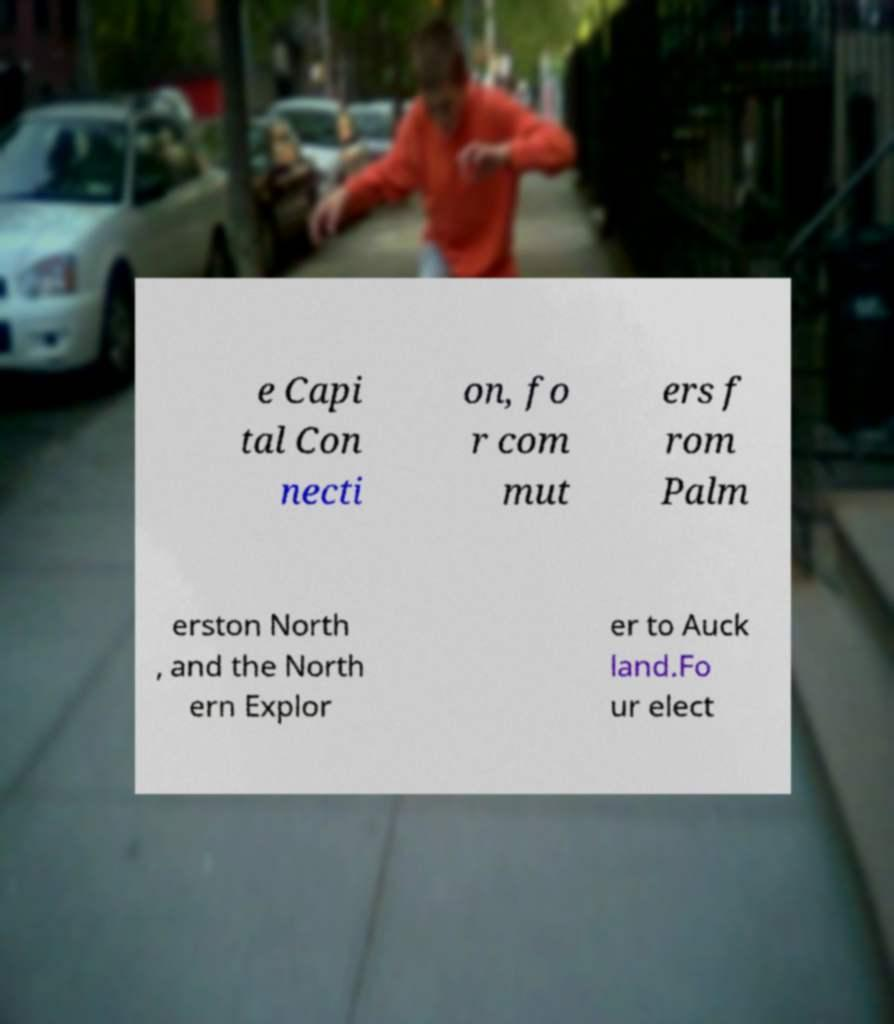Can you read and provide the text displayed in the image?This photo seems to have some interesting text. Can you extract and type it out for me? e Capi tal Con necti on, fo r com mut ers f rom Palm erston North , and the North ern Explor er to Auck land.Fo ur elect 